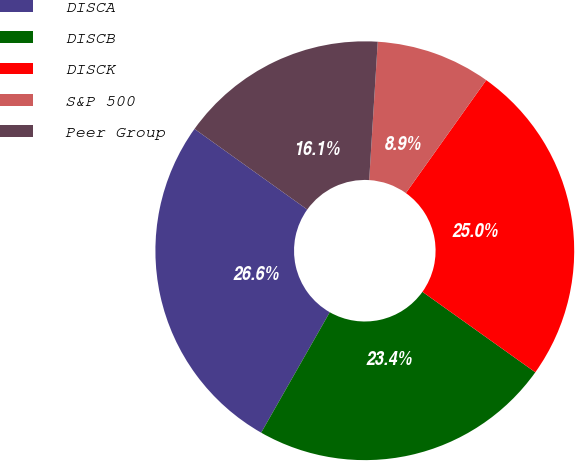Convert chart. <chart><loc_0><loc_0><loc_500><loc_500><pie_chart><fcel>DISCA<fcel>DISCB<fcel>DISCK<fcel>S&P 500<fcel>Peer Group<nl><fcel>26.64%<fcel>23.38%<fcel>25.01%<fcel>8.86%<fcel>16.1%<nl></chart> 